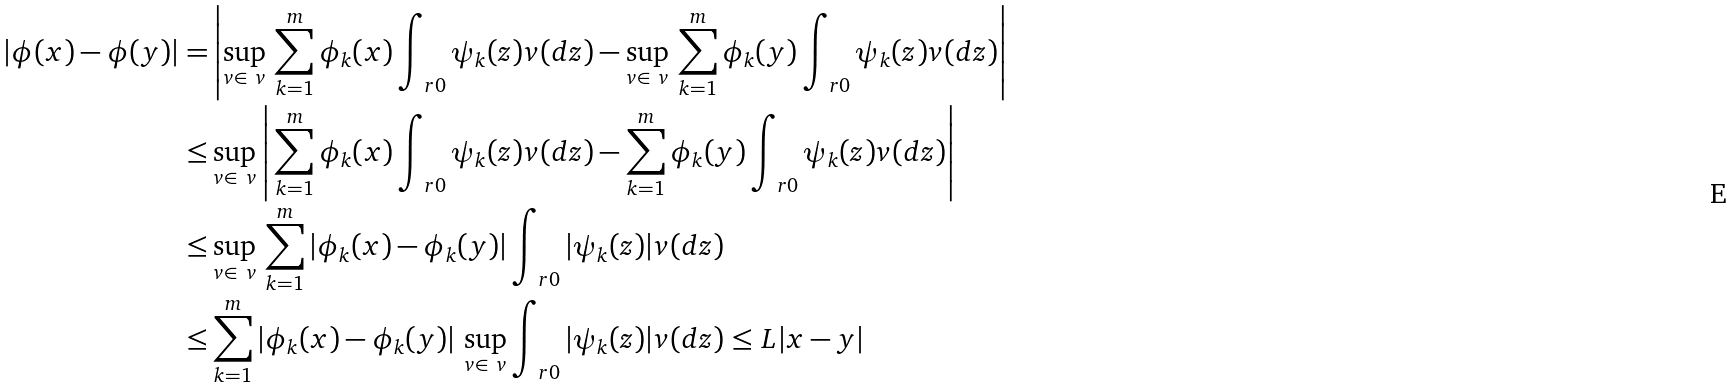<formula> <loc_0><loc_0><loc_500><loc_500>| \phi ( x ) - \phi ( y ) | = & \left | \sup _ { v \in \ v } \, \sum _ { k = 1 } ^ { m } \phi _ { k } ( x ) \int _ { \ r 0 } \psi _ { k } ( z ) v ( d z ) - \sup _ { v \in \ v } \, \sum _ { k = 1 } ^ { m } \phi _ { k } ( y ) \int _ { \ r 0 } \psi _ { k } ( z ) v ( d z ) \right | \\ \leq & \sup _ { v \in \ v } \left | \, \sum _ { k = 1 } ^ { m } \phi _ { k } ( x ) \int _ { \ r 0 } \psi _ { k } ( z ) v ( d z ) - \sum _ { k = 1 } ^ { m } \phi _ { k } ( y ) \int _ { \ r 0 } \psi _ { k } ( z ) v ( d z ) \right | \\ \leq & \sup _ { v \in \ v } \, \sum _ { k = 1 } ^ { m } \left | \phi _ { k } ( x ) - \phi _ { k } ( y ) \right | \int _ { \ r 0 } | \psi _ { k } ( z ) | v ( d z ) \\ \leq & \sum _ { k = 1 } ^ { m } \left | \phi _ { k } ( x ) - \phi _ { k } ( y ) \right | \, \sup _ { v \in \ v } \int _ { \ r 0 } | \psi _ { k } ( z ) | v ( d z ) \leq L | x - y |</formula> 